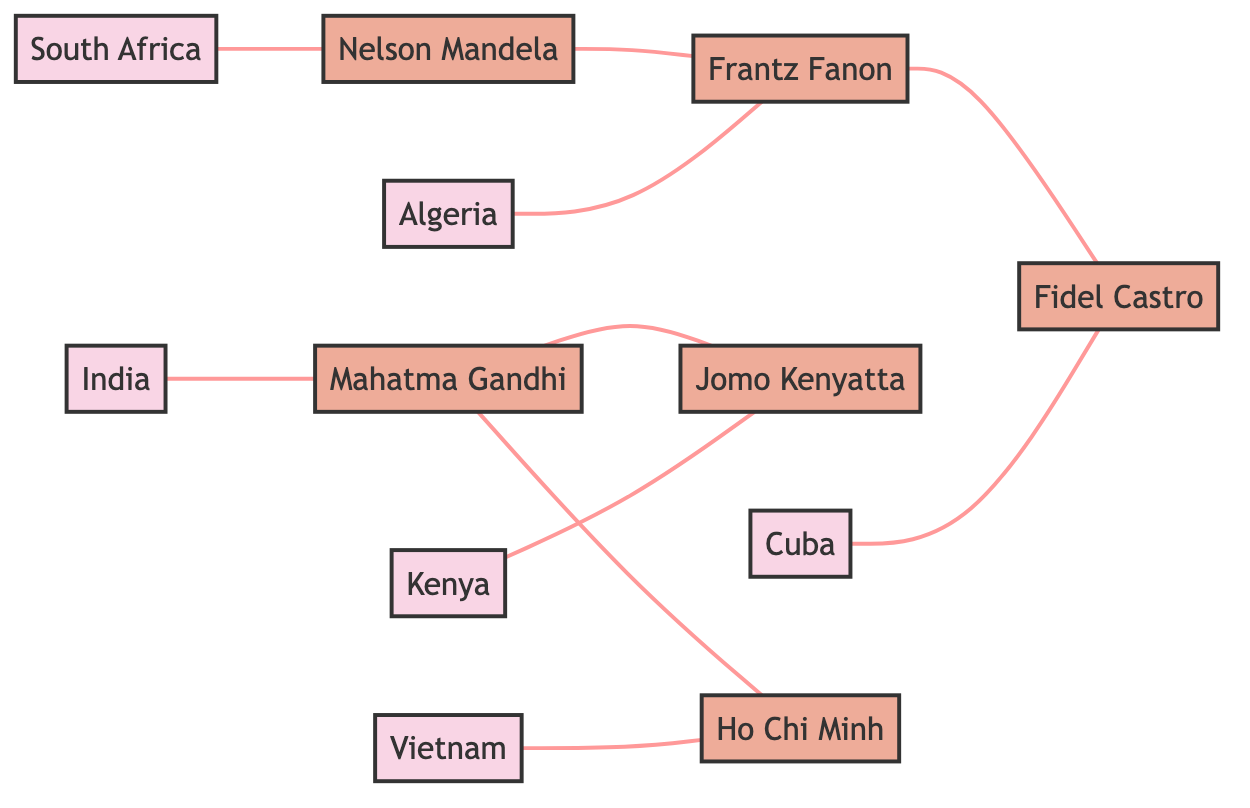What is the total number of nodes in this diagram? The diagram includes a list of nodes: India, Mahatma Gandhi, Kenya, Jomo Kenyatta, Algeria, Frantz Fanon, Vietnam, Ho Chi Minh, Cuba, Fidel Castro, South Africa, and Nelson Mandela. By counting these, we find a total of 12 unique nodes.
Answer: 12 Which country is connected to Mahatma Gandhi? The diagram shows that Mahatma Gandhi is connected to India (his home country) and also to Jomo Kenyatta and Ho Chi Minh. However, the question specifically asks for the country. Since India is explicitly listed as a country and is directly connected, the answer is India.
Answer: India Who connects Algeria to the broader network? From the diagram, we see that Frantz Fanon is the person connected to Algeria. This indicates that he serves as a link between Algeria and the other individuals involved in anti-colonial movements in the diagram.
Answer: Frantz Fanon How many edges are connected to Nelson Mandela? By examining the diagram, we see that Nelson Mandela is connected by edges to two entities: South Africa (the country) and Frantz Fanon. Therefore, we can conclude that there are a total of 2 edges associated with Nelson Mandela.
Answer: 2 Which leader is connected through multiple countries in the networks? Analyzing the diagram, Mahatma Gandhi connects India to both Jomo Kenyatta (Kenya) and Ho Chi Minh (Vietnam). This indicates he serves as a significant node linking multiple countries through different anti-colonial leaders, highlighting his pivotal role in the network.
Answer: Mahatma Gandhi What is the relationship between Frantz Fanon and Fidel Castro? The diagram shows a direct connection (edge) between Frantz Fanon and Fidel Castro. This indicates they share a relationship within the context of anti-colonial movements, suggesting collaboration or ideological alignment between these two leaders.
Answer: Collaboration 